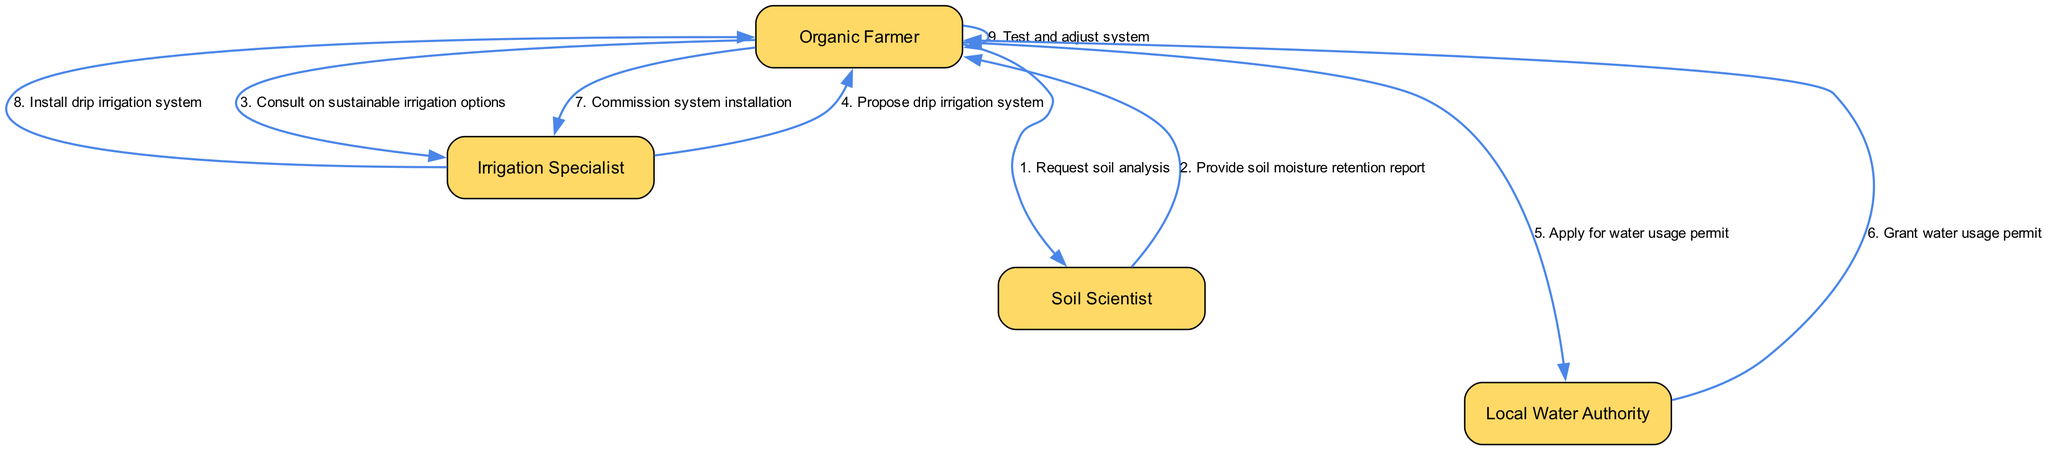What are the actors involved in this sequence diagram? The actors are explicitly listed in the diagram. They include the Organic Farmer, Irrigation Specialist, Soil Scientist, and Local Water Authority. These are the distinct roles represented in the sequence of actions.
Answer: Organic Farmer, Irrigation Specialist, Soil Scientist, Local Water Authority What is the first action performed in this sequence? The first action in the sequence is initiated by the Organic Farmer, who requests a soil analysis from the Soil Scientist. This indicates the start of the process of implementing the irrigation system.
Answer: Request soil analysis How many actions are proposed by the Irrigation Specialist? The Irrigation Specialist proposes one specific action in the diagram, which is the proposal for a drip irrigation system. This is the only instance of action taken by this actor in the sequence displayed.
Answer: One Which actor provides the soil moisture retention report? The Soil Scientist is responsible for providing the soil moisture retention report to the Organic Farmer, detailing important soil data necessary for the irrigation system setup.
Answer: Soil Scientist What is the action taken after the water usage permit is granted? The Organic Farmer commissions the installation of the irrigation system after receiving the water usage permit from the Local Water Authority. This step signifies progress towards the implementation of the irrigation system based on the earlier steps.
Answer: Commission system installation What is the final action in the sequence? The final action listed in the sequence is the Organic Farmer testing and adjusting the irrigation system. This step is crucial for ensuring that the system operates effectively after installation.
Answer: Test and adjust system What is the relationship between the Organic Farmer and the Soil Scientist? The Organic Farmer initiates a request for soil analysis to the Soil Scientist, establishing an interactive relationship in which the farmer relies on the expert advice and data of the scientist. This relationship is foundational for subsequent steps in the irrigation process.
Answer: Request soil analysis How many times does the Organic Farmer interact with the Irrigation Specialist? The Organic Farmer interacts with the Irrigation Specialist two times throughout the sequence. First, they consult on sustainable irrigation options, and then they commission the installation of the proposed system.
Answer: Two times Which actor applies for the water usage permit? The Organic Farmer applies for the water usage permit, which is a critical step in ensuring that the necessary legal permissions are obtained for water usage in the new irrigation system.
Answer: Organic Farmer 